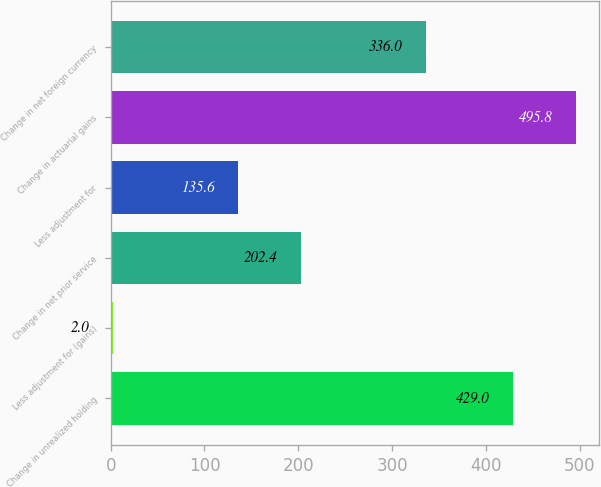<chart> <loc_0><loc_0><loc_500><loc_500><bar_chart><fcel>Change in unrealized holding<fcel>Less adjustment for (gains)<fcel>Change in net prior service<fcel>Less adjustment for<fcel>Change in actuarial gains<fcel>Change in net foreign currency<nl><fcel>429<fcel>2<fcel>202.4<fcel>135.6<fcel>495.8<fcel>336<nl></chart> 